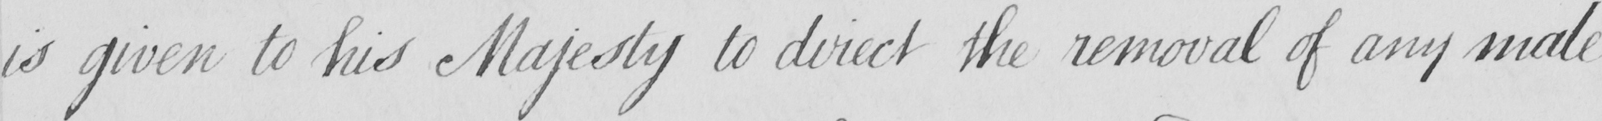Can you read and transcribe this handwriting? is given to his Majesty to direct the removal of any male 